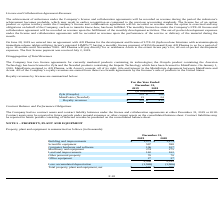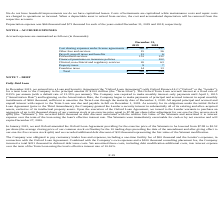According to Acura Pharmaceuticals's financial document, What was the depreciation expense in 2018? According to the financial document, $73 thousand. The relevant text states: "ccounts. Depreciation expense was $66 thousand and $73 thousand for each of the years ended December 31, 2019 and 2018, respectively. NOTE 6 – ACCRUED EXPENSES Accr..." Also, What are the accounting treatments for disposed assets? When a depreciable asset is retired from service, the cost and accumulated depreciation will be removed from the respective accounts.. The document states: "epair costs are charged to operations as incurred. When a depreciable asset is retired from service, the cost and accumulated depreciation will be rem..." Also, What is the net total for property, plant and equipment in 2019? According to the financial document, $ 540 (in thousands). The relevant text states: "Total property, plant and equipment, net $ 540 $ 606..." Also, can you calculate: How much of scientific equipment is being decapitalized from 2018 to 2019?  Based on the calculation: 598 - 597 , the result is 1 (in thousands). This is based on the information: "Scientific equipment 597 598 Scientific equipment 597 598..." The key data points involved are: 597, 598. Also, can you calculate: How much assets were decapitalized from 2018 to 2019? Based on the calculation: 2,512 - 2,509 , the result is 3 (in thousands). This is based on the information: "2,509 2,512 2,509 2,512..." The key data points involved are: 2,509, 2,512. Also, can you calculate: What is the percentage decrease in Net Total Property, Plant and Equipment from 2018 to 2019? To answer this question, I need to perform calculations using the financial data. The calculation is: (606 - 540) / 606 , which equals 10.89 (percentage). This is based on the information: "Total property, plant and equipment, net $ 540 $ 606 Total property, plant and equipment, net $ 540 $ 606..." The key data points involved are: 540, 606. 